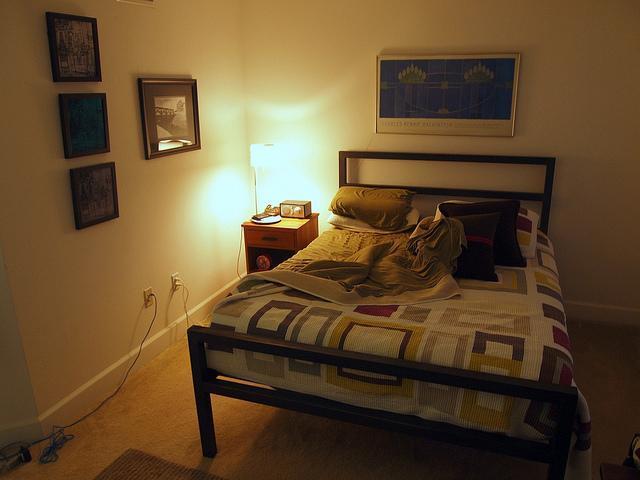How many people are sleeping on the bed?
Give a very brief answer. 0. How many beds are in the room?
Give a very brief answer. 1. How many beds are there?
Give a very brief answer. 1. 